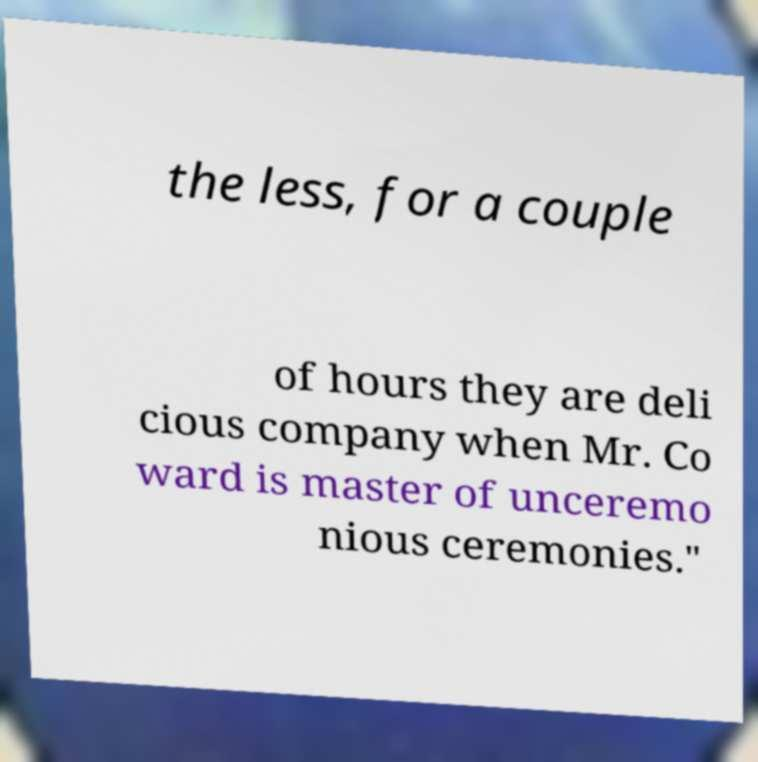What messages or text are displayed in this image? I need them in a readable, typed format. the less, for a couple of hours they are deli cious company when Mr. Co ward is master of unceremo nious ceremonies." 